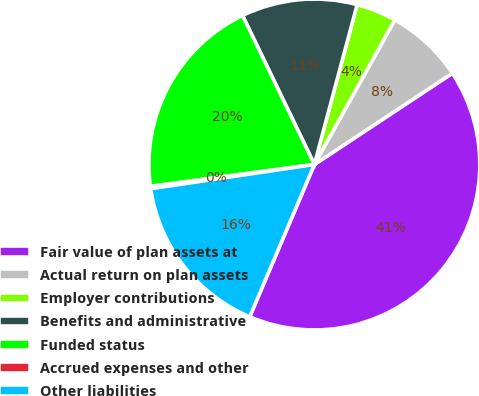<chart> <loc_0><loc_0><loc_500><loc_500><pie_chart><fcel>Fair value of plan assets at<fcel>Actual return on plan assets<fcel>Employer contributions<fcel>Benefits and administrative<fcel>Funded status<fcel>Accrued expenses and other<fcel>Other liabilities<nl><fcel>40.69%<fcel>7.62%<fcel>3.92%<fcel>11.31%<fcel>19.96%<fcel>0.23%<fcel>16.27%<nl></chart> 